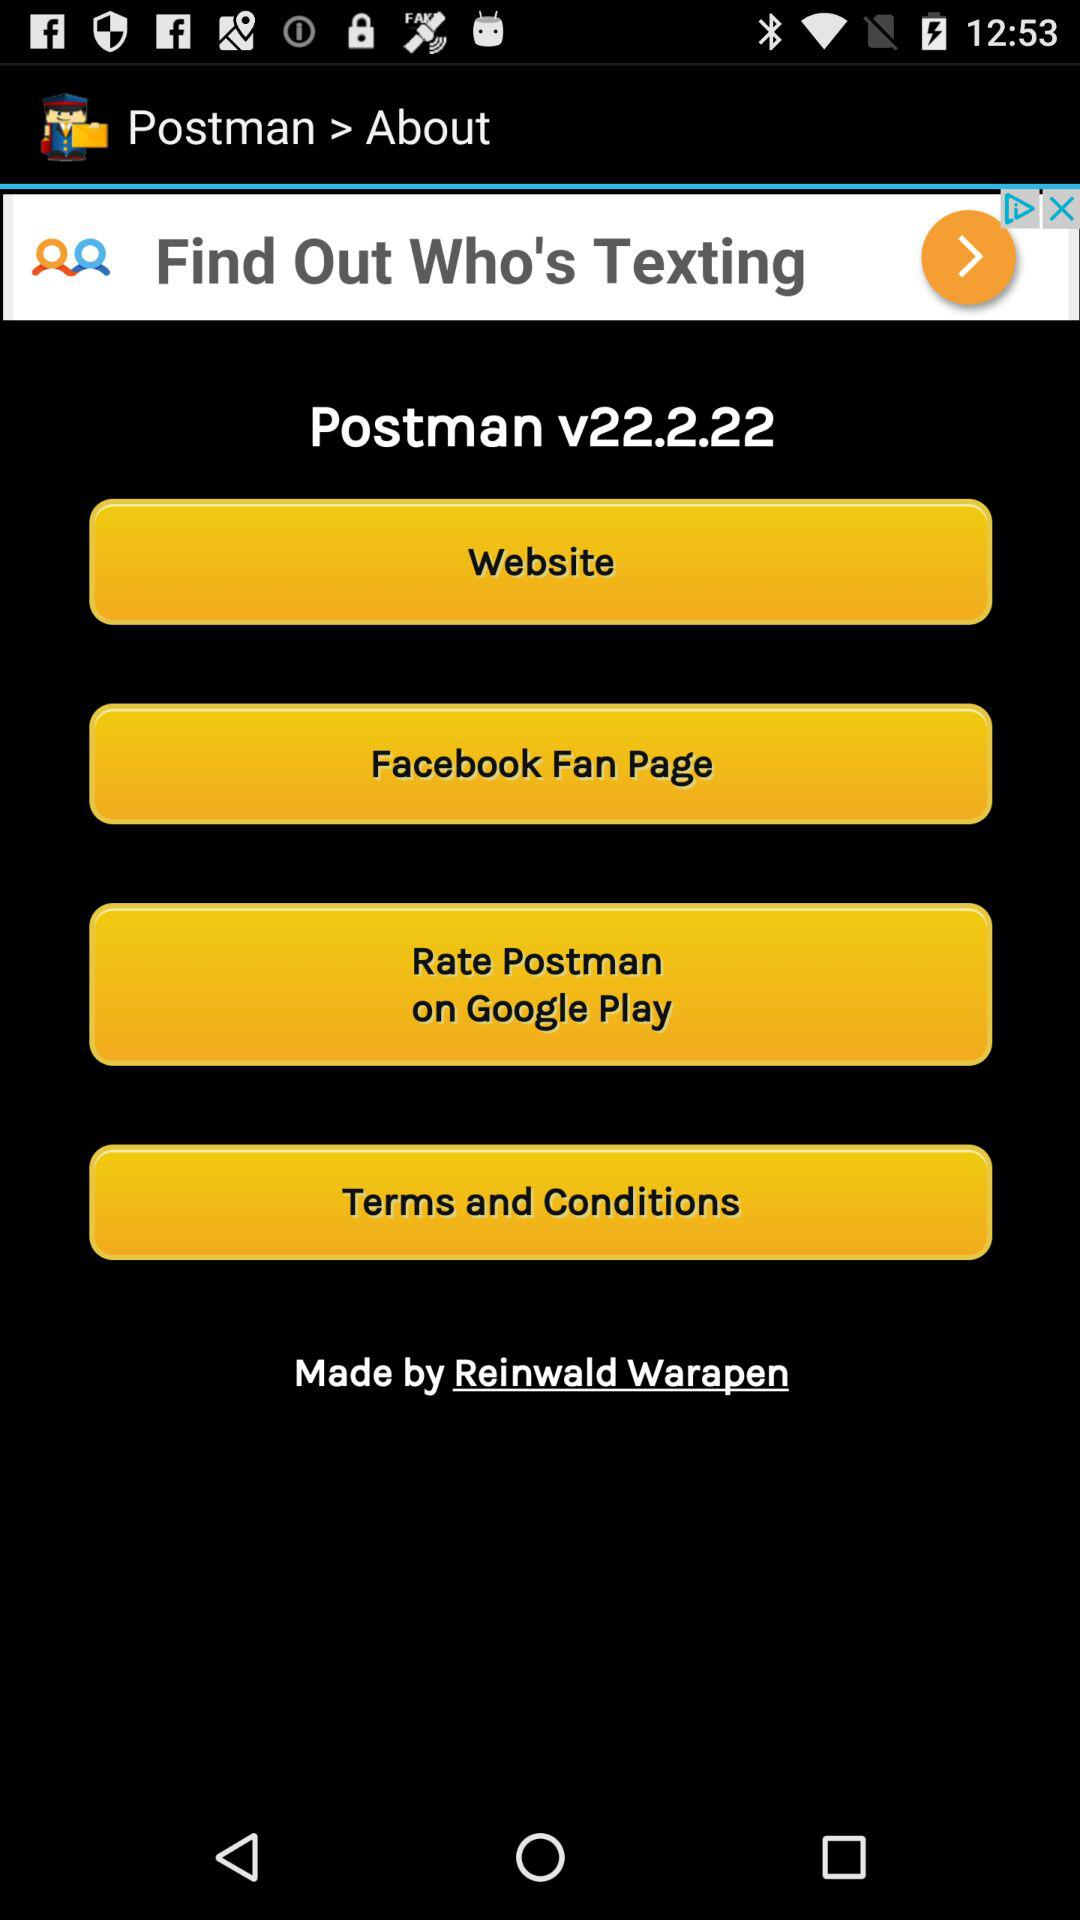What is the version? The version is v22.2.22. 